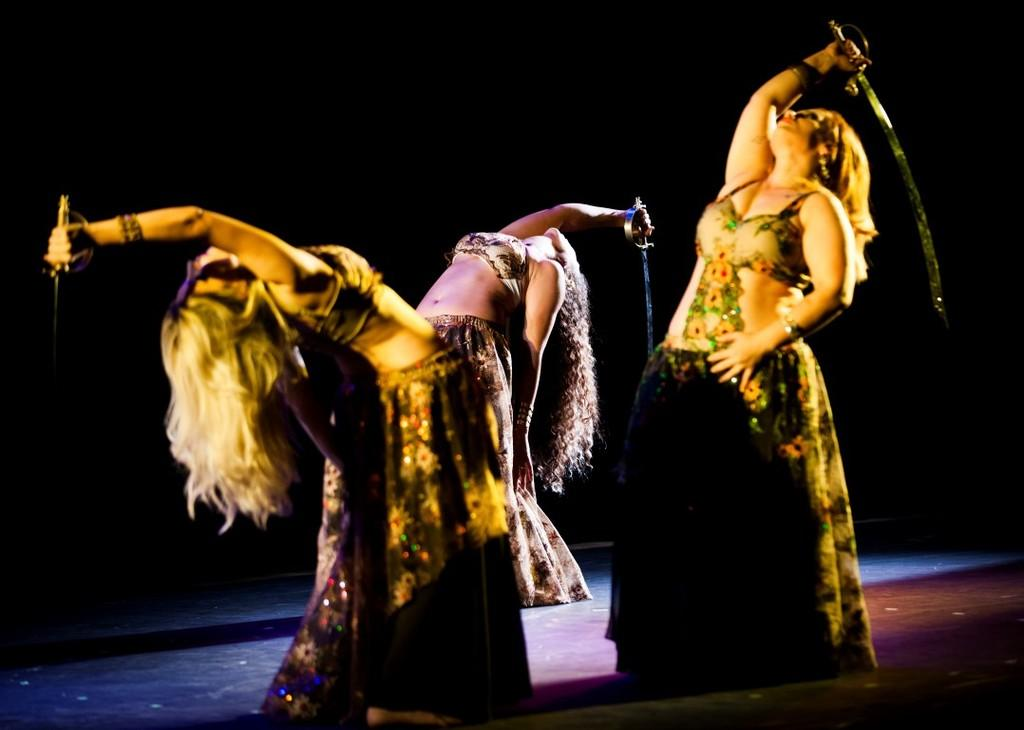How many people are present in the image? There are three people in the image. What are the people wearing? The people are wearing dresses. What are the people holding in their hands? The people are holding weapons. What is the color of the background in the image? The background of the image is black. What type of pie is being served in the image? There is no pie present in the image. Can you solve the riddle that is written on the wall in the image? There is no riddle written on the wall in the image. 